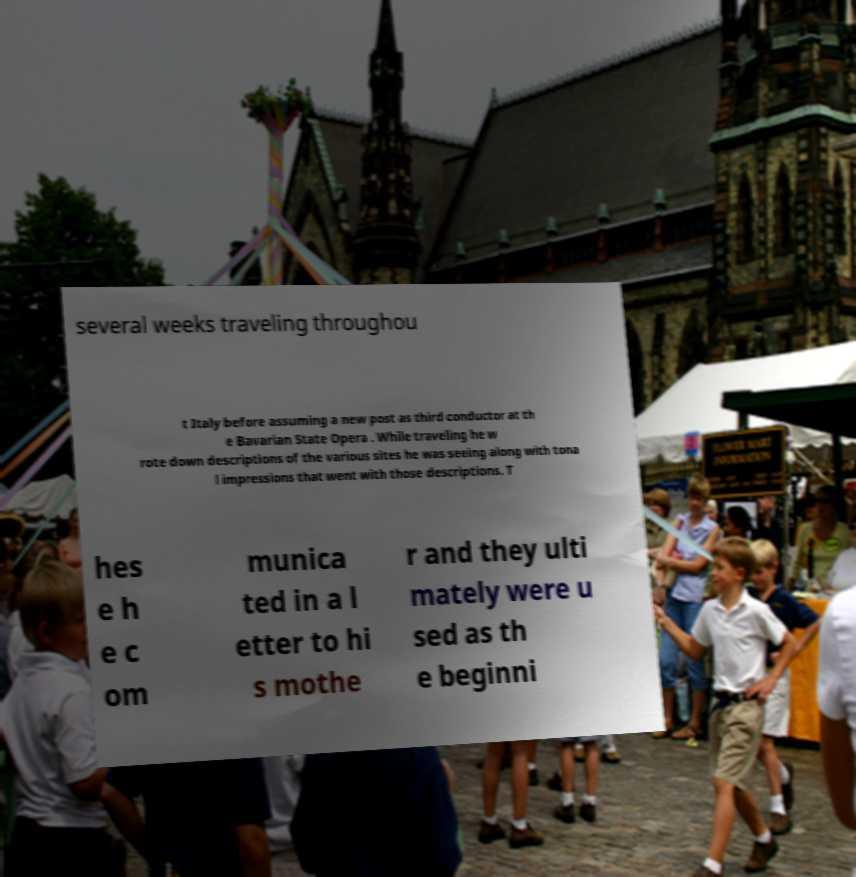Please identify and transcribe the text found in this image. several weeks traveling throughou t Italy before assuming a new post as third conductor at th e Bavarian State Opera . While traveling he w rote down descriptions of the various sites he was seeing along with tona l impressions that went with those descriptions. T hes e h e c om munica ted in a l etter to hi s mothe r and they ulti mately were u sed as th e beginni 